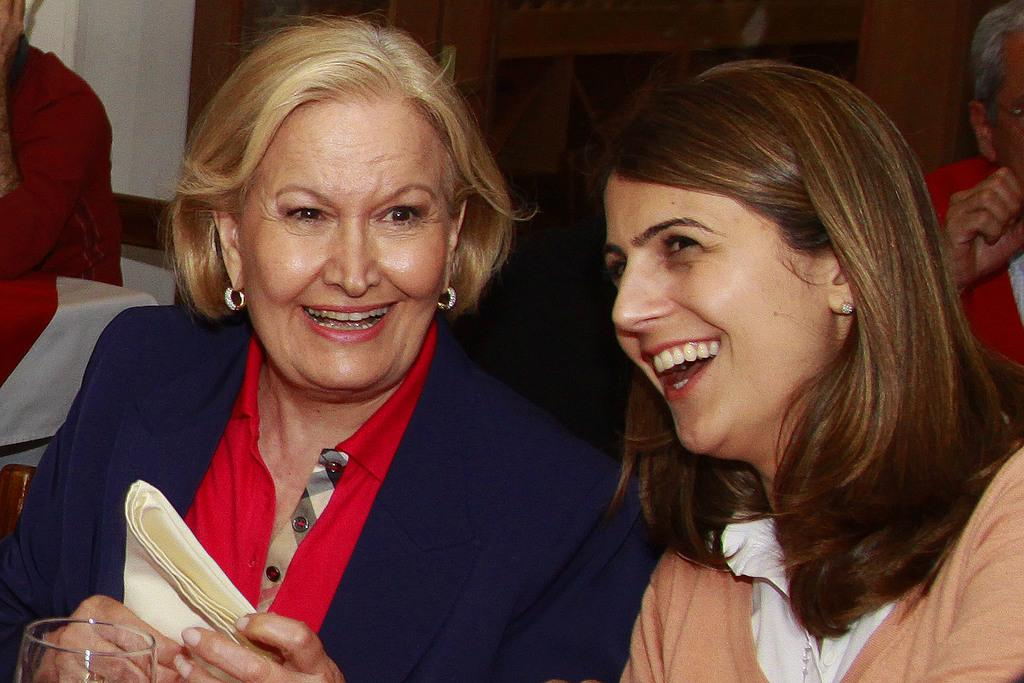How many women are sitting in the front of the image? There are two women sitting in the front of the image. What is one of the women holding in the image? A woman is holding a cloth in the image. Can you describe the seating arrangement in the background of the image? There are other people sitting on chairs in the background of the image. Where is the sink located in the image? There is no sink present in the image. What type of coach can be seen in the image? There is no coach present in the image. 